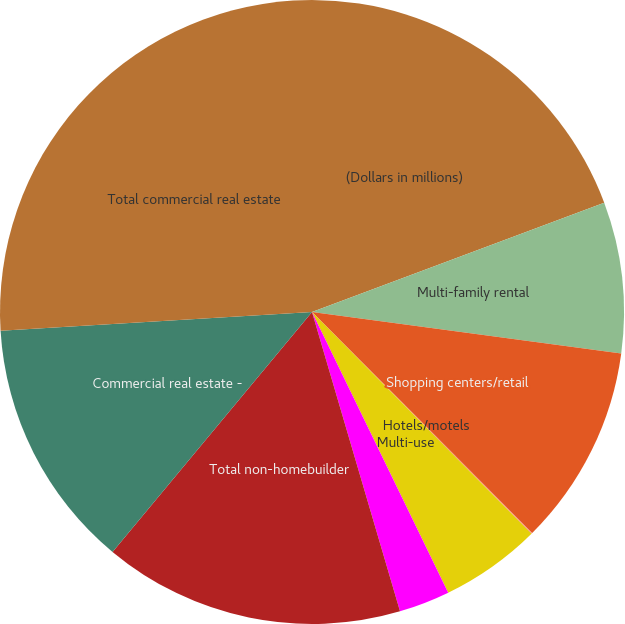Convert chart. <chart><loc_0><loc_0><loc_500><loc_500><pie_chart><fcel>(Dollars in millions)<fcel>Multi-family rental<fcel>Shopping centers/retail<fcel>Hotels/motels<fcel>Multi-use<fcel>Other (4)<fcel>Total non-homebuilder<fcel>Commercial real estate -<fcel>Total commercial real estate<nl><fcel>19.3%<fcel>7.82%<fcel>10.41%<fcel>0.05%<fcel>5.23%<fcel>2.64%<fcel>15.59%<fcel>13.0%<fcel>25.96%<nl></chart> 